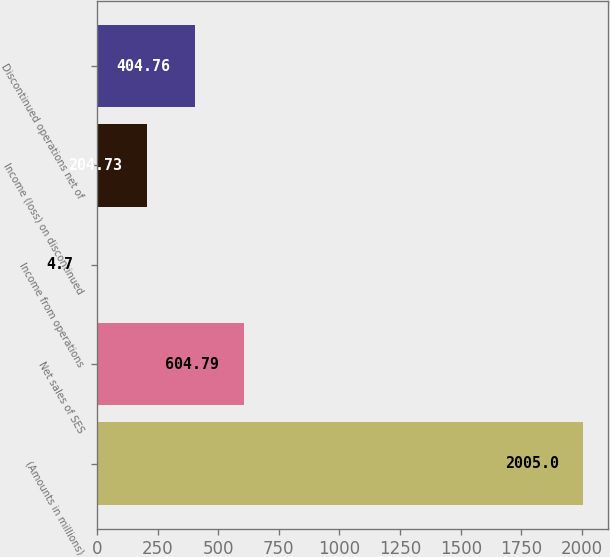Convert chart. <chart><loc_0><loc_0><loc_500><loc_500><bar_chart><fcel>(Amounts in millions)<fcel>Net sales of SES<fcel>Income from operations<fcel>Income (loss) on discontinued<fcel>Discontinued operations net of<nl><fcel>2005<fcel>604.79<fcel>4.7<fcel>204.73<fcel>404.76<nl></chart> 